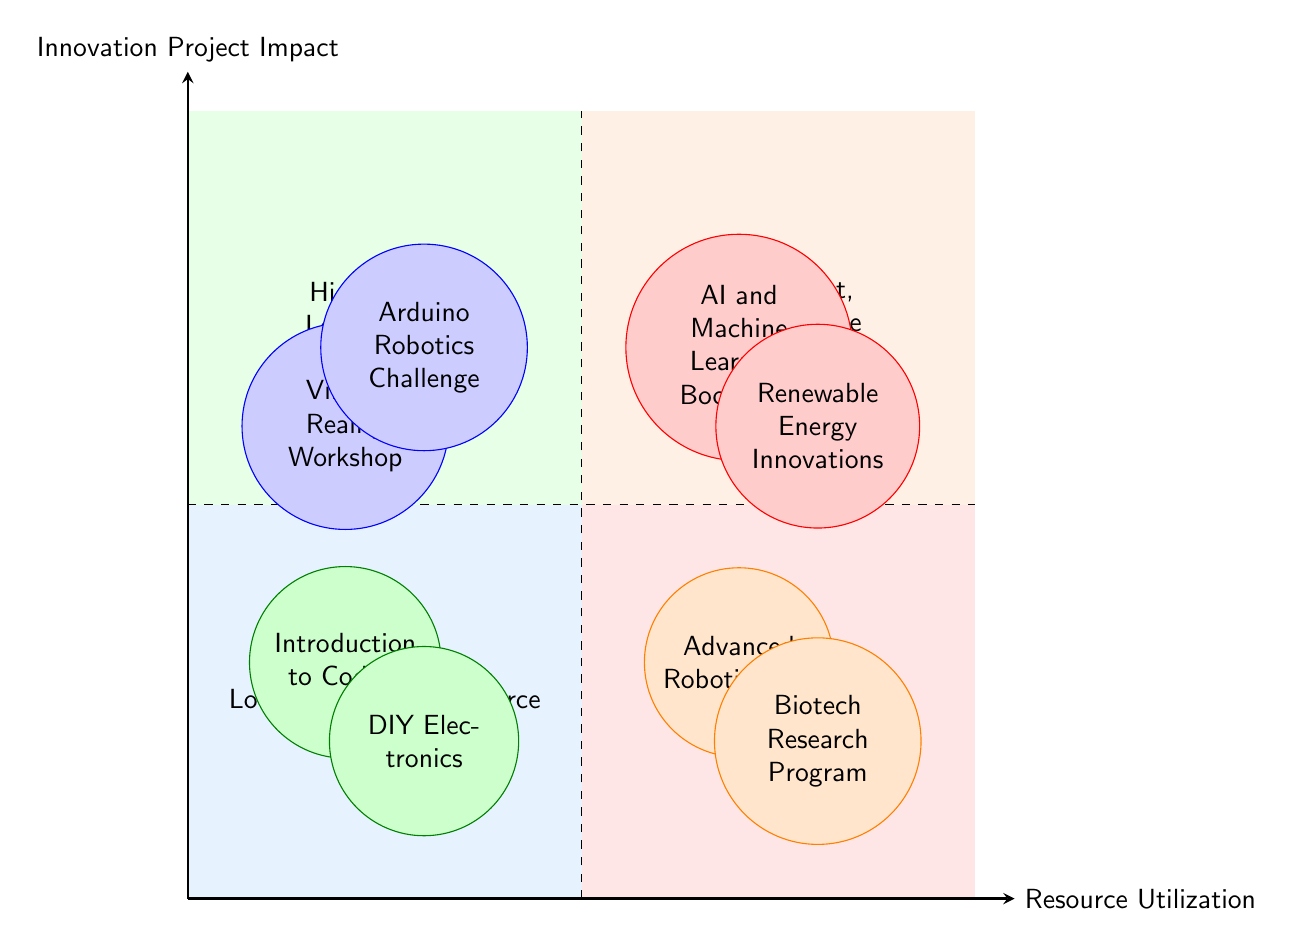What projects are in the High Impact, Low Resource quadrant? The High Impact, Low Resource quadrant contains two projects: "Virtual Reality Workshop" and "Arduino Robotics Challenge." These projects are located in the upper left section of the diagram, which corresponds to high impact but low resource utilization.
Answer: Virtual Reality Workshop, Arduino Robotics Challenge How many total projects are displayed in the diagram? The diagram displays a total of eight projects, as there are two projects in each of the four quadrants. This can be calculated by counting the number of projects listed in each quadrant.
Answer: Eight Which quadrant has no projects? By reviewing the diagram, all four quadrants listed contain at least one project with none being empty. Each quadrant's name corresponds to a combination of impact and resource utilization, but they all feature designated projects.
Answer: None What type of projects are in the Low Impact, High Resource quadrant? The Low Impact, High Resource quadrant contains projects that utilize high resources but have low impact. Specifically, these projects are "Advanced Robotics Lab" and "Biotech Research Program."
Answer: Advanced Robotics Lab, Biotech Research Program Which project is labeled as having High Impact and also requires High Resource? In the High Impact, High Resource quadrant, the "AI and Machine Learning Bootcamp" is specifically labeled as such, sharing the space with "Renewable Energy Innovations." This project represents a blend of high impact along with high resource requirements.
Answer: AI and Machine Learning Bootcamp Which project utilizes low resources but has low impact, and what is its description? The project is "Introduction to Coding," which uses free online resources for basic programming lessons. It is categorized in the Low Impact, Low Resource quadrant, emphasizing cost-effective educational resources with minimal impact.
Answer: Introduction to Coding: Basic programming lessons using free online resources What color represents the High Impact, Low Resource quadrant? The High Impact, Low Resource quadrant is filled with a light blue color, which visually distinguishes it from the other quadrants in the diagram, helping to easily identify it.
Answer: Light blue How many high impact projects are listed in the diagram? The diagram shows four high impact projects: "Virtual Reality Workshop," "Arduino Robotics Challenge," "AI and Machine Learning Bootcamp," and "Renewable Energy Innovations." This total can be determined by counting the projects in the High Impact quadrants.
Answer: Four 